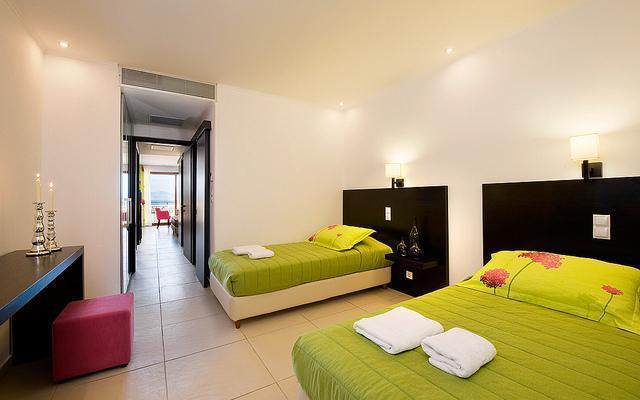How many towels are on each bed?
Give a very brief answer. 2. How many beds are in the picture?
Give a very brief answer. 2. How many clock faces are on the tower?
Give a very brief answer. 0. 